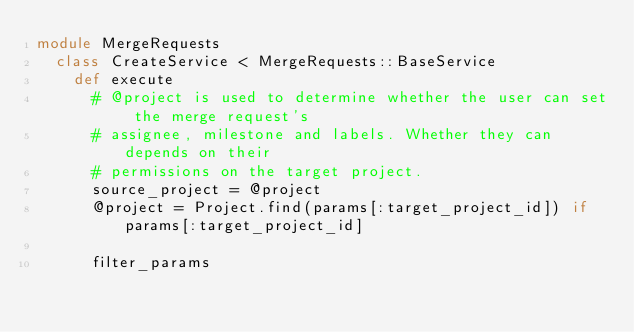Convert code to text. <code><loc_0><loc_0><loc_500><loc_500><_Ruby_>module MergeRequests
  class CreateService < MergeRequests::BaseService
    def execute
      # @project is used to determine whether the user can set the merge request's
      # assignee, milestone and labels. Whether they can depends on their
      # permissions on the target project.
      source_project = @project
      @project = Project.find(params[:target_project_id]) if params[:target_project_id]

      filter_params</code> 